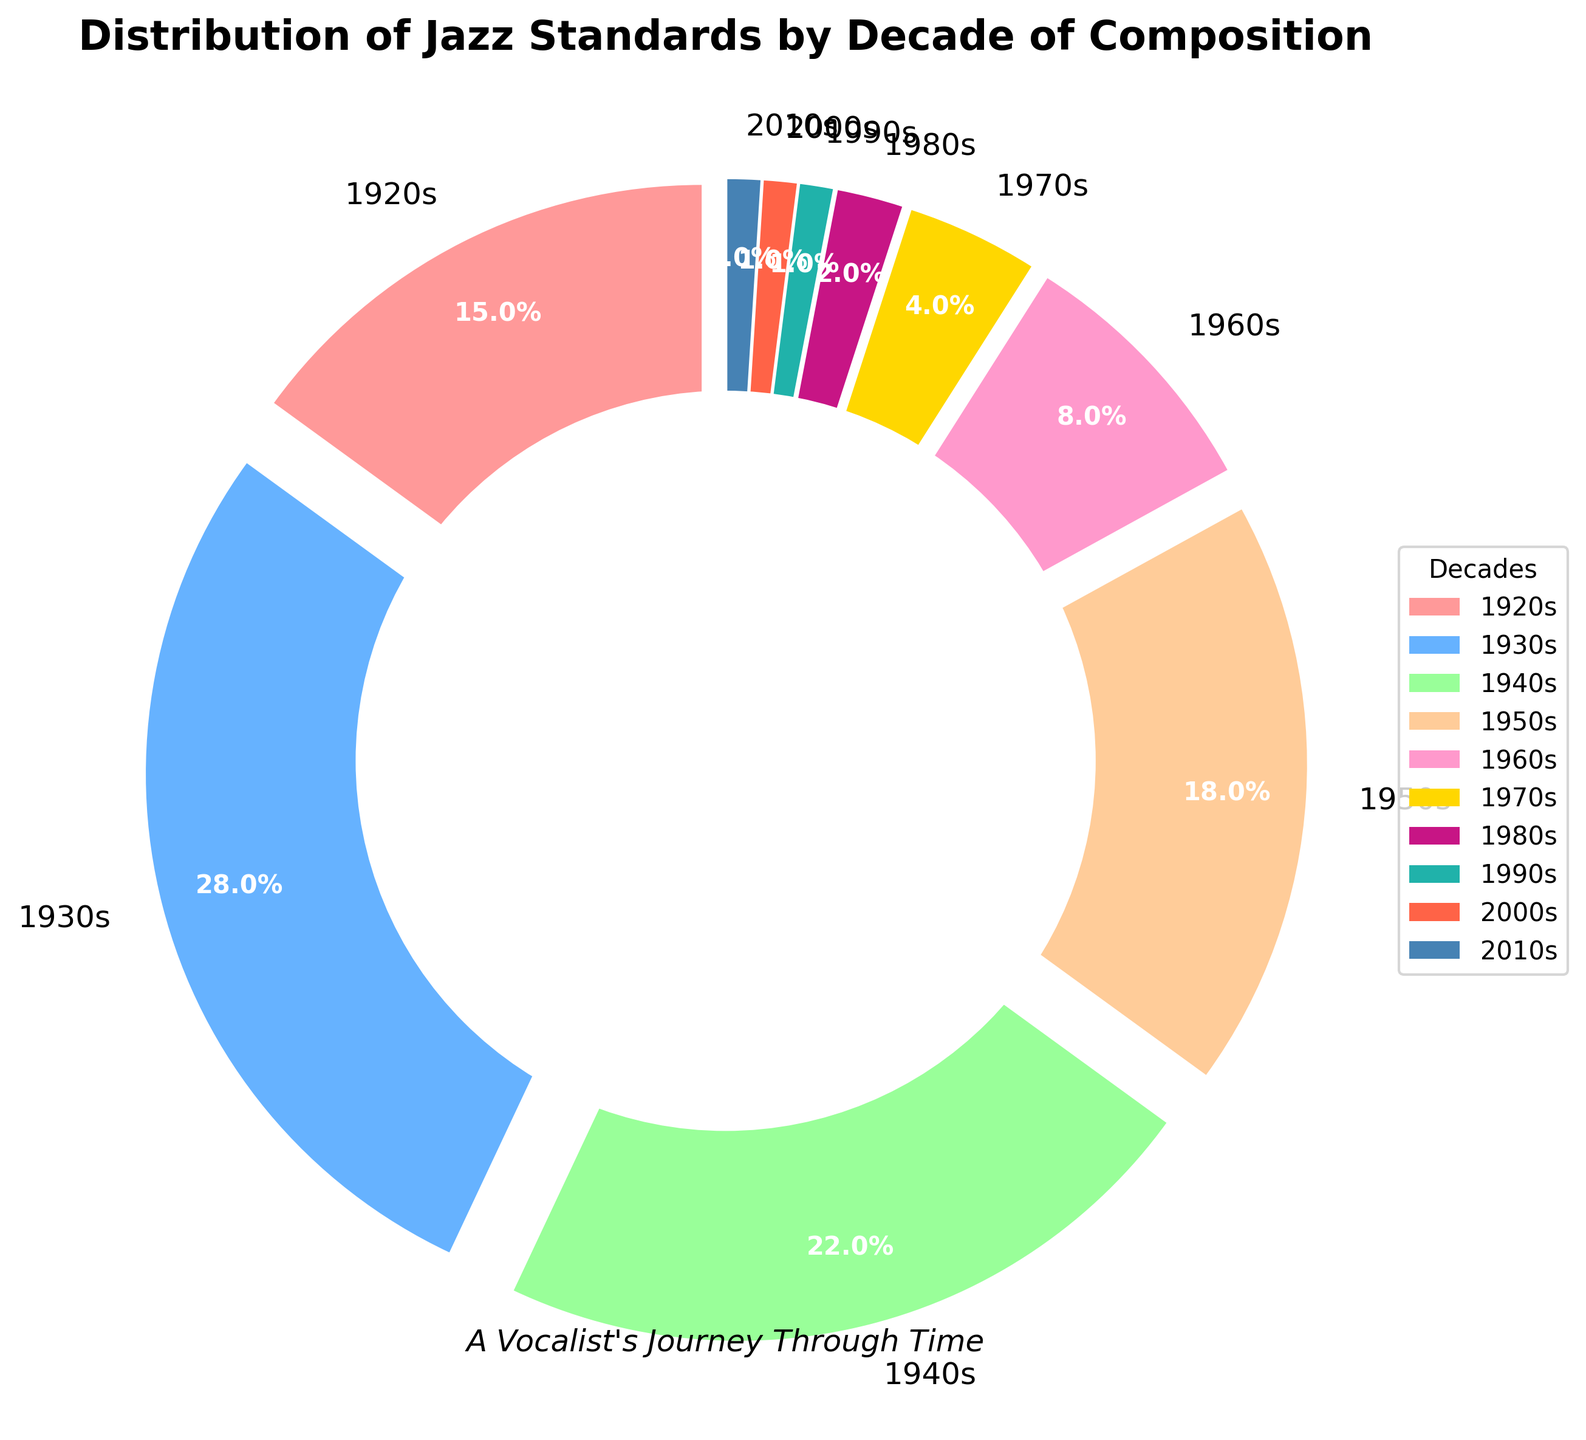Which decade has the highest percentage of jazz standards? First, identify the percentage values for each decade by examining the pie chart. The highest percentage is noted for the 1930s at 28%.
Answer: 1930s By how much does the percentage of jazz standards from the 1940s exceed that from the 1950s? Observe the percentages listed for the 1940s and 1950s, which are 22% and 18%, respectively. Subtract the smaller percentage from the larger one: 22% - 18% = 4%.
Answer: 4% What is the combined percentage of jazz standards from the 2000s, 2010s, and 1990s? Sum the individual percentages for these decades: 1% (2000s) + 1% (2010s) + 1% (1990s) = 3%.
Answer: 3% How does the percentage of jazz standards from the 1960s compare to the percentage from the 1980s? The pie chart reveals a percentage of 8% for the 1960s and 2% for the 1980s. Hence, the 1960s have a significantly higher percentage.
Answer: 1960s have higher What colors are used for the 1930s and the 1970s in the pie chart? The pie chart uses unique colors for each segment. The color for the 1930s is blue, and the color for the 1970s is gold.
Answer: Blue and Gold If you combine the percentages of jazz standards from the 1920s and the 1950s, what is the result? Add the percentages of the 1920s (15%) and the 1950s (18%): 15% + 18% = 33%.
Answer: 33% What is the median percentage value shown in the pie chart? First, list the percentages in ascending order: 1%, 1%, 1%, 2%, 4%, 8%, 15%, 18%, 22%, 28%. The median is the middle value of this dataset. Since there are 10 values, the median is the average of the 5th and 6th values: (4% + 8%)/2 = 6%.
Answer: 6% How many decades have a percentage representation of less than 10%? Identify all decades with a representation of less than 10%. These are the 1960s, 1970s, 1980s, 1990s, 2000s, and 2010s. So, six decades meet this criterion.
Answer: 6 Which decade is represented by a slice colored in magenta-like shade? According to the pie chart’s color coding, the magenta-like shade represents the 1980s.
Answer: 1980s 